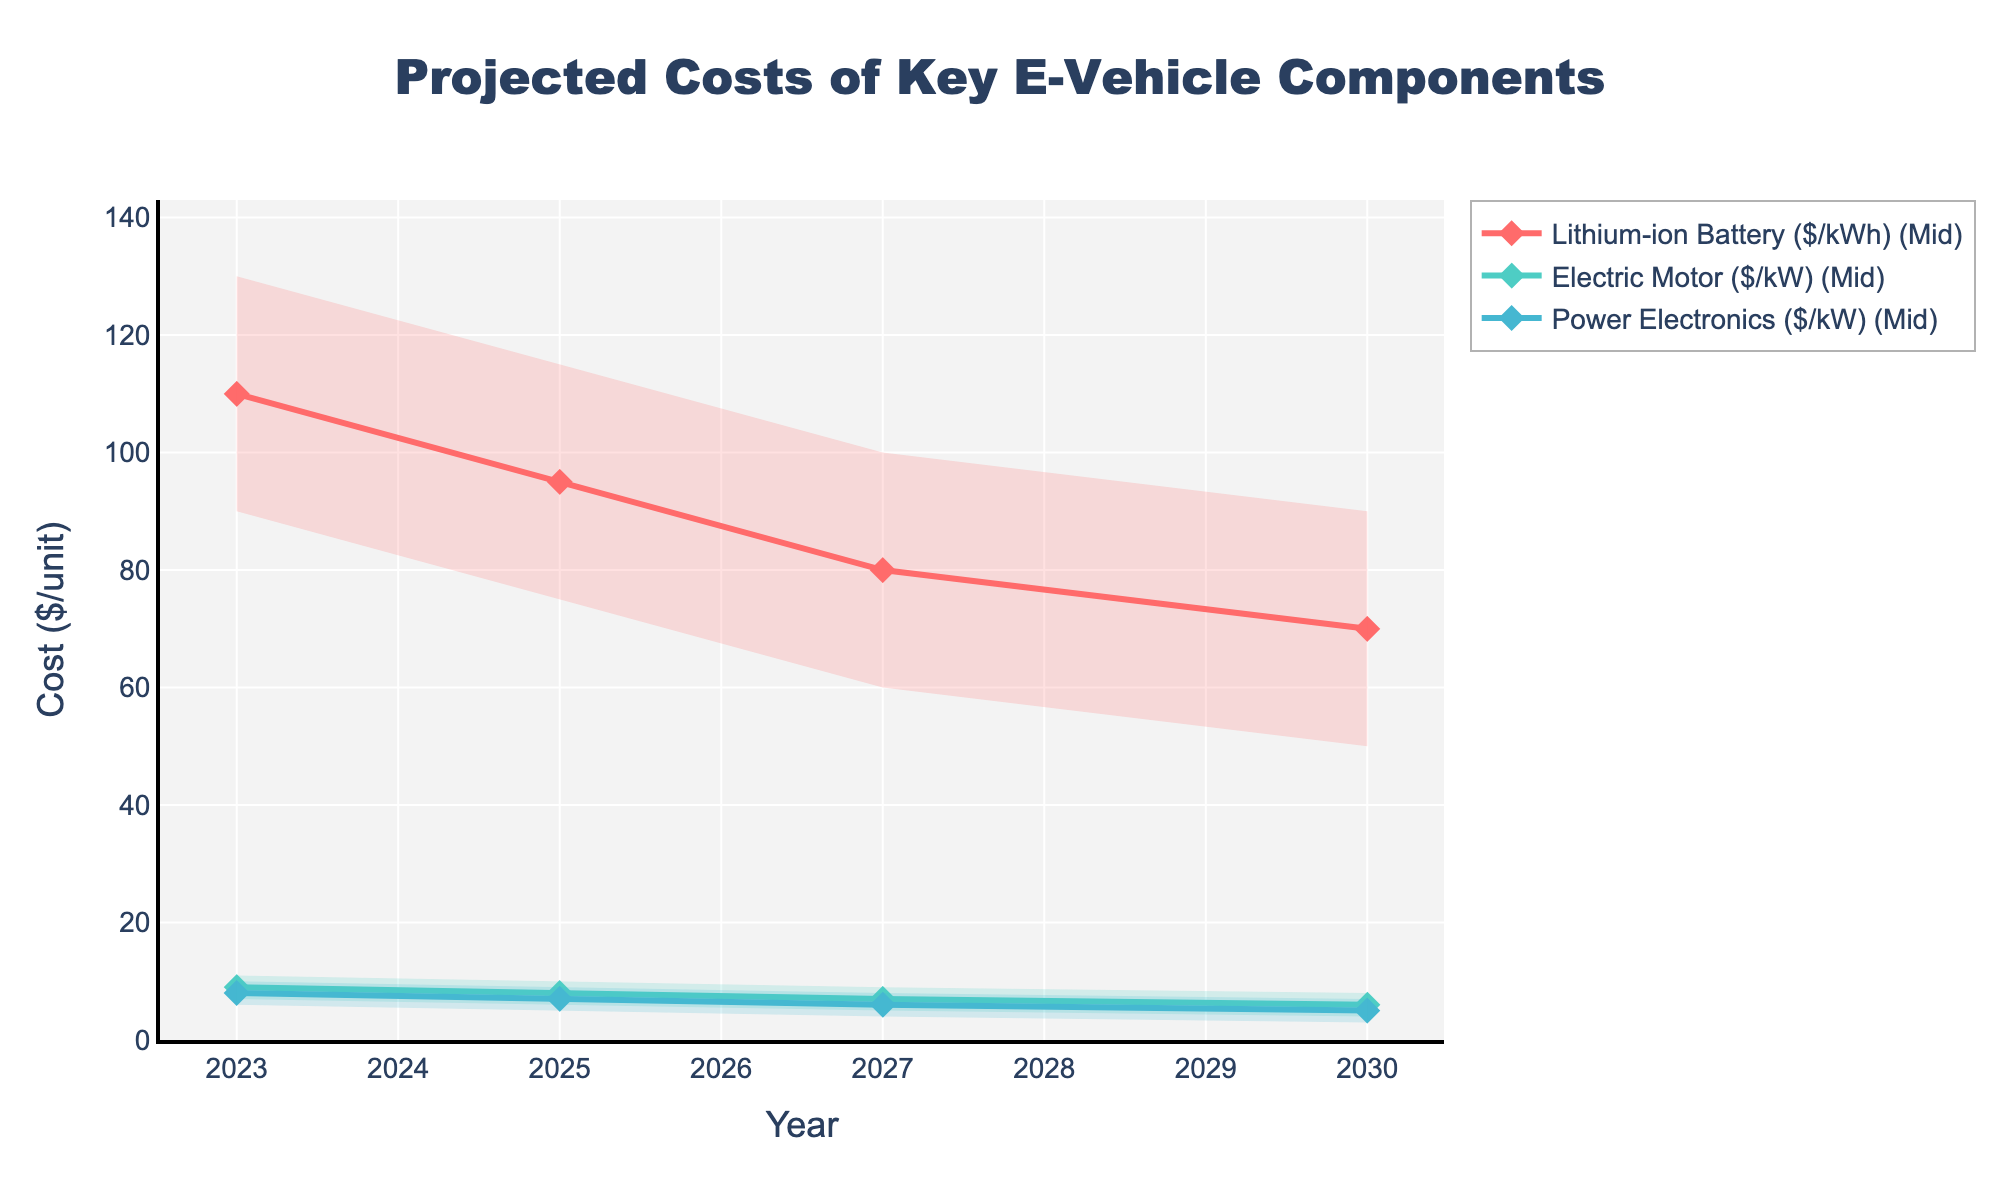What is the title of the figure? The title is displayed at the top of the figure.
Answer: Projected Costs of Key E-Vehicle Components What does the x-axis represent? The x-axis title is shown at the bottom of the figure.
Answer: Year How many components are shown in the figure? There are three distinct colored lines and shaded areas representing different components.
Answer: Three Which component has the highest projected mid-level cost in 2023? Refer to the mid-level markers for each component in the year 2023.
Answer: Lithium-ion Battery ($/kWh) How do the mid-level projected costs of Electric Motor and Power Electronics compare in 2025? Look at the markers for 2025 for both Electric Motor and Power Electronics and compare their mid-level values.
Answer: Both have a mid-level cost of $7/kW What is the range of projected costs for Lithium-ion Battery in 2027? The range is represented by the shaded area for 2027, between the lowest and highest values.
Answer: $60 to $100/kWh By how much does the mid-level projected cost of the Lithium-ion Battery decrease from 2025 to 2030? Subtract the mid-level cost in 2030 from the mid-level cost in 2025. 95 - 70 = 25
Answer: $25/kWh Which component shows the greatest decrease in its mid-level projected cost from 2023 to 2030? Compare the differences between the mid-level costs in 2023 and 2030 for each component.
Answer: Lithium-ion Battery ($/kWh) Is the projected cost decrease for Power Electronics steeper between 2023-2025 or 2027-2030? Calculate the difference between the mid-level costs for each period and compare the values. 2023-2025: 8-7=1, 2027-2030: 6-5=1.
Answer: Same for both periods Which component is projected to have the lowest high-range cost in 2030? Look at the high-range markers for all components in 2030 and identify the lowest value.
Answer: Power Electronics ($/kW) 